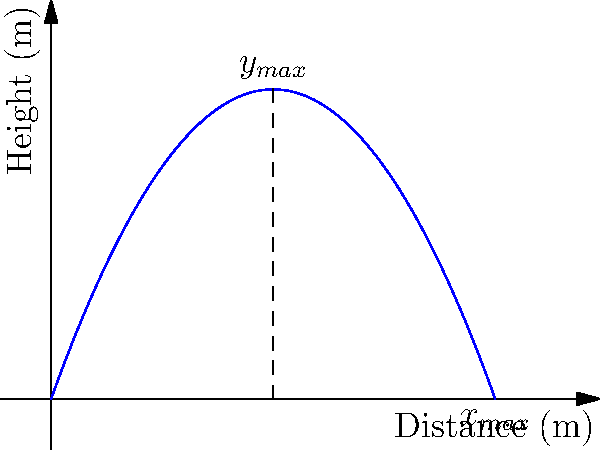Given the trajectory of an artillery shell fired with an initial velocity of 250 m/s at an angle of 30° above the horizontal, as shown in the graph, calculate the maximum range of the projectile. Assume standard gravity ($g = 9.8$ m/s²) and neglect air resistance. How does this compare to the typical range of field artillery used in World War I? To solve this problem, we'll use the equations of projectile motion:

1. The time of flight for a projectile is given by:
   $$t_{flight} = \frac{2v_0 \sin\theta}{g}$$

2. The maximum range is then calculated as:
   $$x_{max} = v_0 \cos\theta \cdot t_{flight}$$

3. Substituting the given values:
   $v_0 = 250$ m/s
   $\theta = 30°$
   $g = 9.8$ m/s²

4. Calculate the time of flight:
   $$t_{flight} = \frac{2 \cdot 250 \cdot \sin(30°)}{9.8} \approx 25.5$ s

5. Calculate the maximum range:
   $$x_{max} = 250 \cdot \cos(30°) \cdot 25.5 \approx 5,526$ m

6. Convert to kilometers:
   $$5,526 \text{ m} = 5.53 \text{ km}$$

Comparing to World War I artillery:
Field artillery in WWI typically had ranges between 4-8 km. The calculated range of 5.53 km falls within this range, representing a mid-range field gun. However, some advanced pieces, like the German Paris Gun, could reach up to 130 km, far exceeding typical field artillery capabilities.
Answer: 5.53 km, within typical WWI field artillery range (4-8 km) 